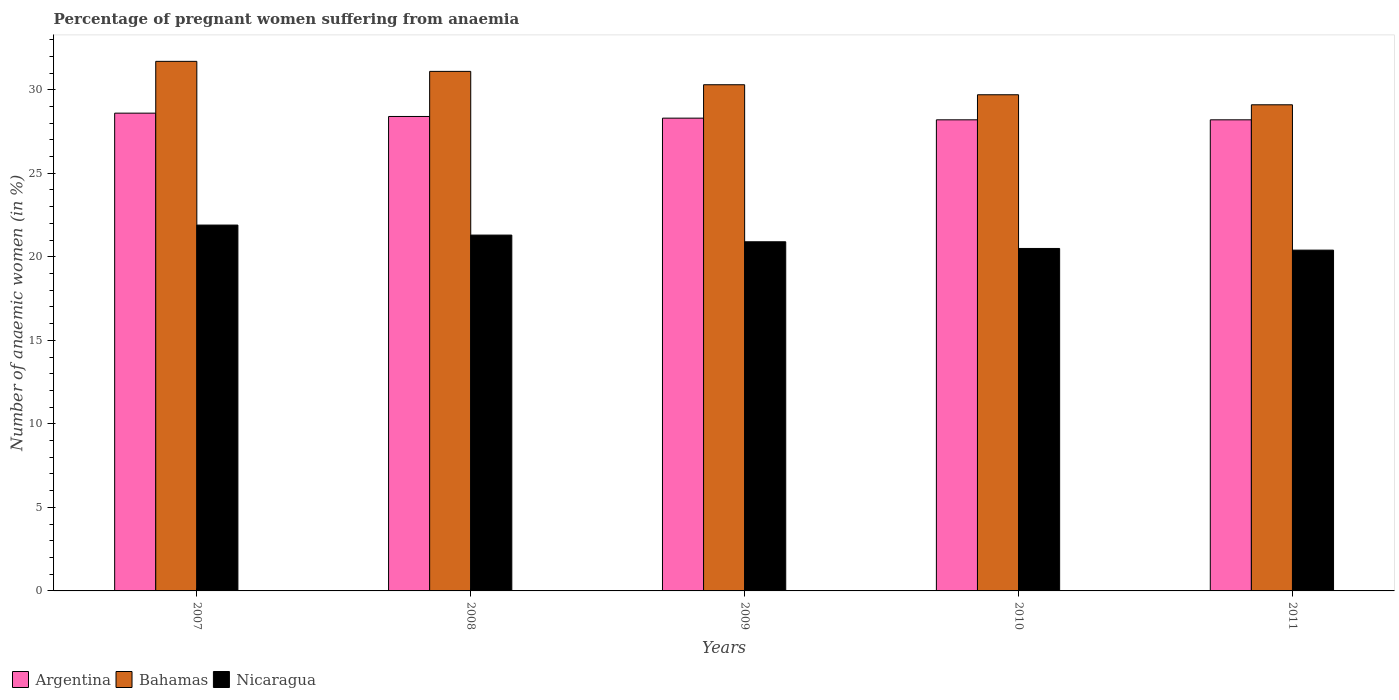How many groups of bars are there?
Offer a terse response. 5. Are the number of bars on each tick of the X-axis equal?
Give a very brief answer. Yes. How many bars are there on the 1st tick from the right?
Give a very brief answer. 3. What is the label of the 1st group of bars from the left?
Ensure brevity in your answer.  2007. What is the number of anaemic women in Nicaragua in 2008?
Ensure brevity in your answer.  21.3. Across all years, what is the maximum number of anaemic women in Argentina?
Provide a short and direct response. 28.6. Across all years, what is the minimum number of anaemic women in Bahamas?
Provide a succinct answer. 29.1. In which year was the number of anaemic women in Bahamas maximum?
Give a very brief answer. 2007. In which year was the number of anaemic women in Nicaragua minimum?
Keep it short and to the point. 2011. What is the total number of anaemic women in Bahamas in the graph?
Make the answer very short. 151.9. What is the difference between the number of anaemic women in Argentina in 2010 and that in 2011?
Offer a very short reply. 0. What is the difference between the number of anaemic women in Argentina in 2007 and the number of anaemic women in Bahamas in 2011?
Ensure brevity in your answer.  -0.5. In the year 2010, what is the difference between the number of anaemic women in Argentina and number of anaemic women in Bahamas?
Offer a terse response. -1.5. What is the ratio of the number of anaemic women in Bahamas in 2007 to that in 2008?
Offer a terse response. 1.02. What is the difference between the highest and the second highest number of anaemic women in Bahamas?
Make the answer very short. 0.6. What does the 2nd bar from the left in 2009 represents?
Your answer should be compact. Bahamas. What does the 2nd bar from the right in 2010 represents?
Offer a very short reply. Bahamas. Is it the case that in every year, the sum of the number of anaemic women in Bahamas and number of anaemic women in Argentina is greater than the number of anaemic women in Nicaragua?
Ensure brevity in your answer.  Yes. How many bars are there?
Your answer should be compact. 15. Are all the bars in the graph horizontal?
Make the answer very short. No. What is the difference between two consecutive major ticks on the Y-axis?
Offer a very short reply. 5. Are the values on the major ticks of Y-axis written in scientific E-notation?
Keep it short and to the point. No. Where does the legend appear in the graph?
Make the answer very short. Bottom left. How many legend labels are there?
Make the answer very short. 3. How are the legend labels stacked?
Provide a short and direct response. Horizontal. What is the title of the graph?
Keep it short and to the point. Percentage of pregnant women suffering from anaemia. What is the label or title of the Y-axis?
Offer a terse response. Number of anaemic women (in %). What is the Number of anaemic women (in %) in Argentina in 2007?
Keep it short and to the point. 28.6. What is the Number of anaemic women (in %) in Bahamas in 2007?
Offer a very short reply. 31.7. What is the Number of anaemic women (in %) in Nicaragua in 2007?
Provide a succinct answer. 21.9. What is the Number of anaemic women (in %) of Argentina in 2008?
Give a very brief answer. 28.4. What is the Number of anaemic women (in %) in Bahamas in 2008?
Your answer should be very brief. 31.1. What is the Number of anaemic women (in %) of Nicaragua in 2008?
Provide a short and direct response. 21.3. What is the Number of anaemic women (in %) of Argentina in 2009?
Provide a succinct answer. 28.3. What is the Number of anaemic women (in %) in Bahamas in 2009?
Your answer should be compact. 30.3. What is the Number of anaemic women (in %) in Nicaragua in 2009?
Your answer should be compact. 20.9. What is the Number of anaemic women (in %) in Argentina in 2010?
Offer a very short reply. 28.2. What is the Number of anaemic women (in %) of Bahamas in 2010?
Your answer should be very brief. 29.7. What is the Number of anaemic women (in %) of Argentina in 2011?
Your answer should be compact. 28.2. What is the Number of anaemic women (in %) in Bahamas in 2011?
Make the answer very short. 29.1. What is the Number of anaemic women (in %) in Nicaragua in 2011?
Make the answer very short. 20.4. Across all years, what is the maximum Number of anaemic women (in %) in Argentina?
Your answer should be compact. 28.6. Across all years, what is the maximum Number of anaemic women (in %) in Bahamas?
Ensure brevity in your answer.  31.7. Across all years, what is the maximum Number of anaemic women (in %) of Nicaragua?
Offer a terse response. 21.9. Across all years, what is the minimum Number of anaemic women (in %) of Argentina?
Your answer should be compact. 28.2. Across all years, what is the minimum Number of anaemic women (in %) in Bahamas?
Offer a terse response. 29.1. Across all years, what is the minimum Number of anaemic women (in %) of Nicaragua?
Offer a very short reply. 20.4. What is the total Number of anaemic women (in %) of Argentina in the graph?
Your response must be concise. 141.7. What is the total Number of anaemic women (in %) in Bahamas in the graph?
Give a very brief answer. 151.9. What is the total Number of anaemic women (in %) of Nicaragua in the graph?
Your response must be concise. 105. What is the difference between the Number of anaemic women (in %) of Bahamas in 2007 and that in 2008?
Ensure brevity in your answer.  0.6. What is the difference between the Number of anaemic women (in %) of Nicaragua in 2007 and that in 2010?
Give a very brief answer. 1.4. What is the difference between the Number of anaemic women (in %) in Argentina in 2007 and that in 2011?
Provide a short and direct response. 0.4. What is the difference between the Number of anaemic women (in %) of Bahamas in 2007 and that in 2011?
Offer a very short reply. 2.6. What is the difference between the Number of anaemic women (in %) in Argentina in 2008 and that in 2009?
Your response must be concise. 0.1. What is the difference between the Number of anaemic women (in %) in Bahamas in 2008 and that in 2009?
Make the answer very short. 0.8. What is the difference between the Number of anaemic women (in %) of Nicaragua in 2008 and that in 2009?
Provide a short and direct response. 0.4. What is the difference between the Number of anaemic women (in %) of Argentina in 2008 and that in 2010?
Provide a short and direct response. 0.2. What is the difference between the Number of anaemic women (in %) of Bahamas in 2008 and that in 2010?
Offer a terse response. 1.4. What is the difference between the Number of anaemic women (in %) of Nicaragua in 2008 and that in 2011?
Offer a terse response. 0.9. What is the difference between the Number of anaemic women (in %) in Argentina in 2009 and that in 2011?
Offer a very short reply. 0.1. What is the difference between the Number of anaemic women (in %) of Nicaragua in 2009 and that in 2011?
Offer a terse response. 0.5. What is the difference between the Number of anaemic women (in %) in Bahamas in 2010 and that in 2011?
Give a very brief answer. 0.6. What is the difference between the Number of anaemic women (in %) in Argentina in 2007 and the Number of anaemic women (in %) in Nicaragua in 2008?
Your answer should be compact. 7.3. What is the difference between the Number of anaemic women (in %) of Bahamas in 2007 and the Number of anaemic women (in %) of Nicaragua in 2008?
Offer a very short reply. 10.4. What is the difference between the Number of anaemic women (in %) in Argentina in 2007 and the Number of anaemic women (in %) in Bahamas in 2009?
Provide a short and direct response. -1.7. What is the difference between the Number of anaemic women (in %) in Argentina in 2007 and the Number of anaemic women (in %) in Nicaragua in 2009?
Your answer should be compact. 7.7. What is the difference between the Number of anaemic women (in %) in Bahamas in 2007 and the Number of anaemic women (in %) in Nicaragua in 2009?
Ensure brevity in your answer.  10.8. What is the difference between the Number of anaemic women (in %) in Argentina in 2007 and the Number of anaemic women (in %) in Bahamas in 2010?
Your answer should be compact. -1.1. What is the difference between the Number of anaemic women (in %) in Argentina in 2007 and the Number of anaemic women (in %) in Bahamas in 2011?
Your answer should be very brief. -0.5. What is the difference between the Number of anaemic women (in %) in Argentina in 2007 and the Number of anaemic women (in %) in Nicaragua in 2011?
Keep it short and to the point. 8.2. What is the difference between the Number of anaemic women (in %) of Bahamas in 2007 and the Number of anaemic women (in %) of Nicaragua in 2011?
Make the answer very short. 11.3. What is the difference between the Number of anaemic women (in %) in Argentina in 2008 and the Number of anaemic women (in %) in Nicaragua in 2009?
Give a very brief answer. 7.5. What is the difference between the Number of anaemic women (in %) of Bahamas in 2008 and the Number of anaemic women (in %) of Nicaragua in 2009?
Your answer should be compact. 10.2. What is the difference between the Number of anaemic women (in %) in Argentina in 2008 and the Number of anaemic women (in %) in Bahamas in 2010?
Your answer should be very brief. -1.3. What is the difference between the Number of anaemic women (in %) in Argentina in 2008 and the Number of anaemic women (in %) in Nicaragua in 2010?
Make the answer very short. 7.9. What is the difference between the Number of anaemic women (in %) of Argentina in 2008 and the Number of anaemic women (in %) of Nicaragua in 2011?
Offer a very short reply. 8. What is the difference between the Number of anaemic women (in %) of Argentina in 2009 and the Number of anaemic women (in %) of Bahamas in 2010?
Ensure brevity in your answer.  -1.4. What is the difference between the Number of anaemic women (in %) of Argentina in 2009 and the Number of anaemic women (in %) of Nicaragua in 2010?
Make the answer very short. 7.8. What is the difference between the Number of anaemic women (in %) in Argentina in 2009 and the Number of anaemic women (in %) in Nicaragua in 2011?
Ensure brevity in your answer.  7.9. What is the average Number of anaemic women (in %) in Argentina per year?
Offer a very short reply. 28.34. What is the average Number of anaemic women (in %) of Bahamas per year?
Give a very brief answer. 30.38. What is the average Number of anaemic women (in %) in Nicaragua per year?
Offer a very short reply. 21. In the year 2007, what is the difference between the Number of anaemic women (in %) of Argentina and Number of anaemic women (in %) of Bahamas?
Your answer should be compact. -3.1. In the year 2007, what is the difference between the Number of anaemic women (in %) in Argentina and Number of anaemic women (in %) in Nicaragua?
Offer a terse response. 6.7. In the year 2007, what is the difference between the Number of anaemic women (in %) of Bahamas and Number of anaemic women (in %) of Nicaragua?
Provide a short and direct response. 9.8. In the year 2008, what is the difference between the Number of anaemic women (in %) in Argentina and Number of anaemic women (in %) in Nicaragua?
Your answer should be compact. 7.1. In the year 2008, what is the difference between the Number of anaemic women (in %) in Bahamas and Number of anaemic women (in %) in Nicaragua?
Offer a very short reply. 9.8. In the year 2009, what is the difference between the Number of anaemic women (in %) in Argentina and Number of anaemic women (in %) in Bahamas?
Your answer should be compact. -2. In the year 2009, what is the difference between the Number of anaemic women (in %) in Bahamas and Number of anaemic women (in %) in Nicaragua?
Make the answer very short. 9.4. In the year 2010, what is the difference between the Number of anaemic women (in %) of Argentina and Number of anaemic women (in %) of Nicaragua?
Give a very brief answer. 7.7. In the year 2010, what is the difference between the Number of anaemic women (in %) in Bahamas and Number of anaemic women (in %) in Nicaragua?
Keep it short and to the point. 9.2. What is the ratio of the Number of anaemic women (in %) in Argentina in 2007 to that in 2008?
Offer a very short reply. 1.01. What is the ratio of the Number of anaemic women (in %) of Bahamas in 2007 to that in 2008?
Your answer should be compact. 1.02. What is the ratio of the Number of anaemic women (in %) in Nicaragua in 2007 to that in 2008?
Offer a terse response. 1.03. What is the ratio of the Number of anaemic women (in %) of Argentina in 2007 to that in 2009?
Provide a succinct answer. 1.01. What is the ratio of the Number of anaemic women (in %) in Bahamas in 2007 to that in 2009?
Keep it short and to the point. 1.05. What is the ratio of the Number of anaemic women (in %) in Nicaragua in 2007 to that in 2009?
Keep it short and to the point. 1.05. What is the ratio of the Number of anaemic women (in %) in Argentina in 2007 to that in 2010?
Provide a succinct answer. 1.01. What is the ratio of the Number of anaemic women (in %) of Bahamas in 2007 to that in 2010?
Keep it short and to the point. 1.07. What is the ratio of the Number of anaemic women (in %) of Nicaragua in 2007 to that in 2010?
Your response must be concise. 1.07. What is the ratio of the Number of anaemic women (in %) in Argentina in 2007 to that in 2011?
Give a very brief answer. 1.01. What is the ratio of the Number of anaemic women (in %) in Bahamas in 2007 to that in 2011?
Your answer should be compact. 1.09. What is the ratio of the Number of anaemic women (in %) of Nicaragua in 2007 to that in 2011?
Make the answer very short. 1.07. What is the ratio of the Number of anaemic women (in %) in Bahamas in 2008 to that in 2009?
Give a very brief answer. 1.03. What is the ratio of the Number of anaemic women (in %) of Nicaragua in 2008 to that in 2009?
Offer a terse response. 1.02. What is the ratio of the Number of anaemic women (in %) of Argentina in 2008 to that in 2010?
Your response must be concise. 1.01. What is the ratio of the Number of anaemic women (in %) in Bahamas in 2008 to that in 2010?
Offer a very short reply. 1.05. What is the ratio of the Number of anaemic women (in %) in Nicaragua in 2008 to that in 2010?
Your answer should be very brief. 1.04. What is the ratio of the Number of anaemic women (in %) in Argentina in 2008 to that in 2011?
Your response must be concise. 1.01. What is the ratio of the Number of anaemic women (in %) in Bahamas in 2008 to that in 2011?
Ensure brevity in your answer.  1.07. What is the ratio of the Number of anaemic women (in %) of Nicaragua in 2008 to that in 2011?
Your response must be concise. 1.04. What is the ratio of the Number of anaemic women (in %) of Bahamas in 2009 to that in 2010?
Offer a very short reply. 1.02. What is the ratio of the Number of anaemic women (in %) of Nicaragua in 2009 to that in 2010?
Provide a succinct answer. 1.02. What is the ratio of the Number of anaemic women (in %) of Argentina in 2009 to that in 2011?
Provide a short and direct response. 1. What is the ratio of the Number of anaemic women (in %) in Bahamas in 2009 to that in 2011?
Keep it short and to the point. 1.04. What is the ratio of the Number of anaemic women (in %) in Nicaragua in 2009 to that in 2011?
Offer a very short reply. 1.02. What is the ratio of the Number of anaemic women (in %) of Bahamas in 2010 to that in 2011?
Your response must be concise. 1.02. What is the difference between the highest and the lowest Number of anaemic women (in %) of Bahamas?
Keep it short and to the point. 2.6. 